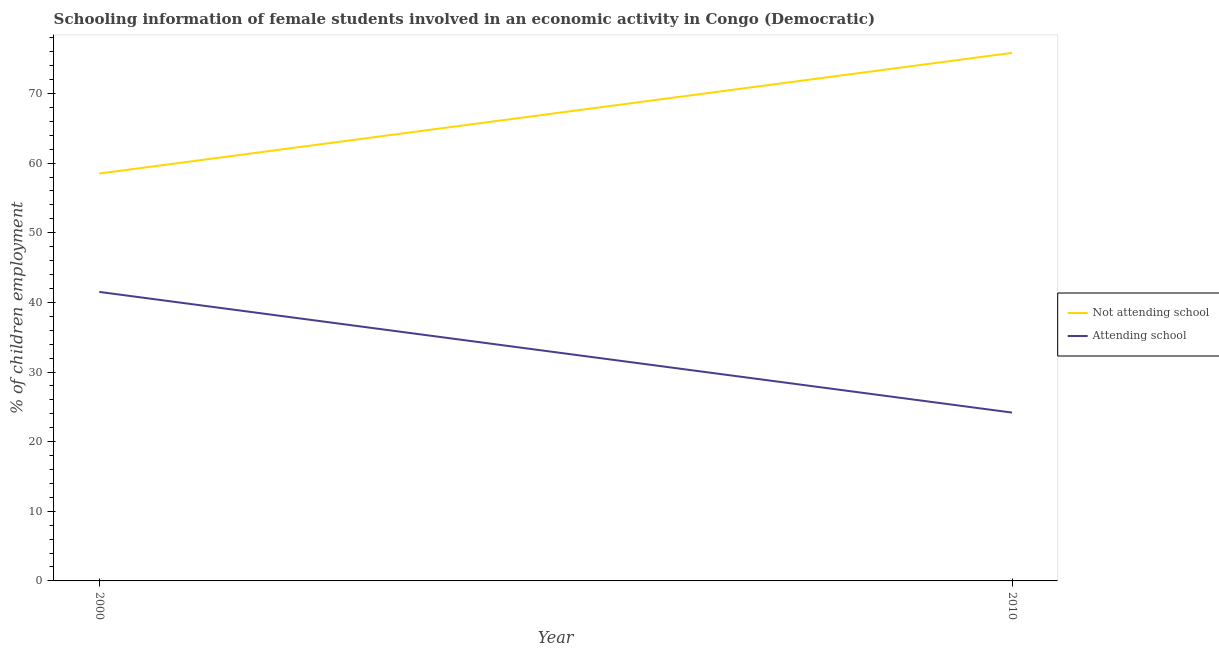Does the line corresponding to percentage of employed females who are not attending school intersect with the line corresponding to percentage of employed females who are attending school?
Provide a short and direct response. No. What is the percentage of employed females who are not attending school in 2010?
Your answer should be compact. 75.83. Across all years, what is the maximum percentage of employed females who are not attending school?
Provide a succinct answer. 75.83. Across all years, what is the minimum percentage of employed females who are attending school?
Provide a short and direct response. 24.17. In which year was the percentage of employed females who are attending school maximum?
Give a very brief answer. 2000. What is the total percentage of employed females who are not attending school in the graph?
Your answer should be very brief. 134.33. What is the difference between the percentage of employed females who are attending school in 2000 and that in 2010?
Your answer should be very brief. 17.33. What is the difference between the percentage of employed females who are not attending school in 2010 and the percentage of employed females who are attending school in 2000?
Offer a very short reply. 34.33. What is the average percentage of employed females who are attending school per year?
Give a very brief answer. 32.84. In the year 2010, what is the difference between the percentage of employed females who are not attending school and percentage of employed females who are attending school?
Ensure brevity in your answer.  51.66. In how many years, is the percentage of employed females who are attending school greater than 56 %?
Provide a short and direct response. 0. What is the ratio of the percentage of employed females who are attending school in 2000 to that in 2010?
Keep it short and to the point. 1.72. Is the percentage of employed females who are not attending school strictly greater than the percentage of employed females who are attending school over the years?
Your answer should be very brief. Yes. Is the percentage of employed females who are not attending school strictly less than the percentage of employed females who are attending school over the years?
Your response must be concise. No. Does the graph contain grids?
Your response must be concise. No. Where does the legend appear in the graph?
Your response must be concise. Center right. How are the legend labels stacked?
Make the answer very short. Vertical. What is the title of the graph?
Your answer should be compact. Schooling information of female students involved in an economic activity in Congo (Democratic). What is the label or title of the X-axis?
Your response must be concise. Year. What is the label or title of the Y-axis?
Keep it short and to the point. % of children employment. What is the % of children employment of Not attending school in 2000?
Ensure brevity in your answer.  58.5. What is the % of children employment in Attending school in 2000?
Your response must be concise. 41.5. What is the % of children employment of Not attending school in 2010?
Give a very brief answer. 75.83. What is the % of children employment of Attending school in 2010?
Your response must be concise. 24.17. Across all years, what is the maximum % of children employment of Not attending school?
Provide a short and direct response. 75.83. Across all years, what is the maximum % of children employment in Attending school?
Your answer should be very brief. 41.5. Across all years, what is the minimum % of children employment in Not attending school?
Offer a terse response. 58.5. Across all years, what is the minimum % of children employment of Attending school?
Your answer should be very brief. 24.17. What is the total % of children employment of Not attending school in the graph?
Keep it short and to the point. 134.33. What is the total % of children employment of Attending school in the graph?
Provide a succinct answer. 65.67. What is the difference between the % of children employment in Not attending school in 2000 and that in 2010?
Your response must be concise. -17.33. What is the difference between the % of children employment of Attending school in 2000 and that in 2010?
Keep it short and to the point. 17.33. What is the difference between the % of children employment in Not attending school in 2000 and the % of children employment in Attending school in 2010?
Keep it short and to the point. 34.33. What is the average % of children employment of Not attending school per year?
Offer a very short reply. 67.16. What is the average % of children employment of Attending school per year?
Give a very brief answer. 32.84. In the year 2010, what is the difference between the % of children employment in Not attending school and % of children employment in Attending school?
Offer a very short reply. 51.66. What is the ratio of the % of children employment in Not attending school in 2000 to that in 2010?
Ensure brevity in your answer.  0.77. What is the ratio of the % of children employment of Attending school in 2000 to that in 2010?
Offer a very short reply. 1.72. What is the difference between the highest and the second highest % of children employment in Not attending school?
Provide a succinct answer. 17.33. What is the difference between the highest and the second highest % of children employment in Attending school?
Provide a short and direct response. 17.33. What is the difference between the highest and the lowest % of children employment of Not attending school?
Provide a succinct answer. 17.33. What is the difference between the highest and the lowest % of children employment in Attending school?
Your answer should be very brief. 17.33. 